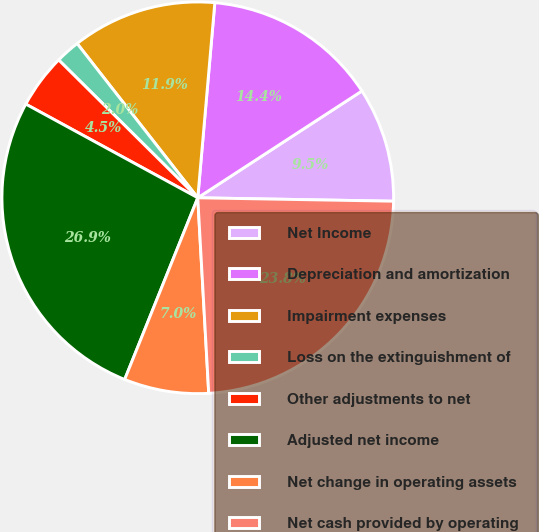Convert chart to OTSL. <chart><loc_0><loc_0><loc_500><loc_500><pie_chart><fcel>Net Income<fcel>Depreciation and amortization<fcel>Impairment expenses<fcel>Loss on the extinguishment of<fcel>Other adjustments to net<fcel>Adjusted net income<fcel>Net change in operating assets<fcel>Net cash provided by operating<nl><fcel>9.46%<fcel>14.43%<fcel>11.95%<fcel>2.01%<fcel>4.49%<fcel>26.85%<fcel>6.98%<fcel>23.83%<nl></chart> 